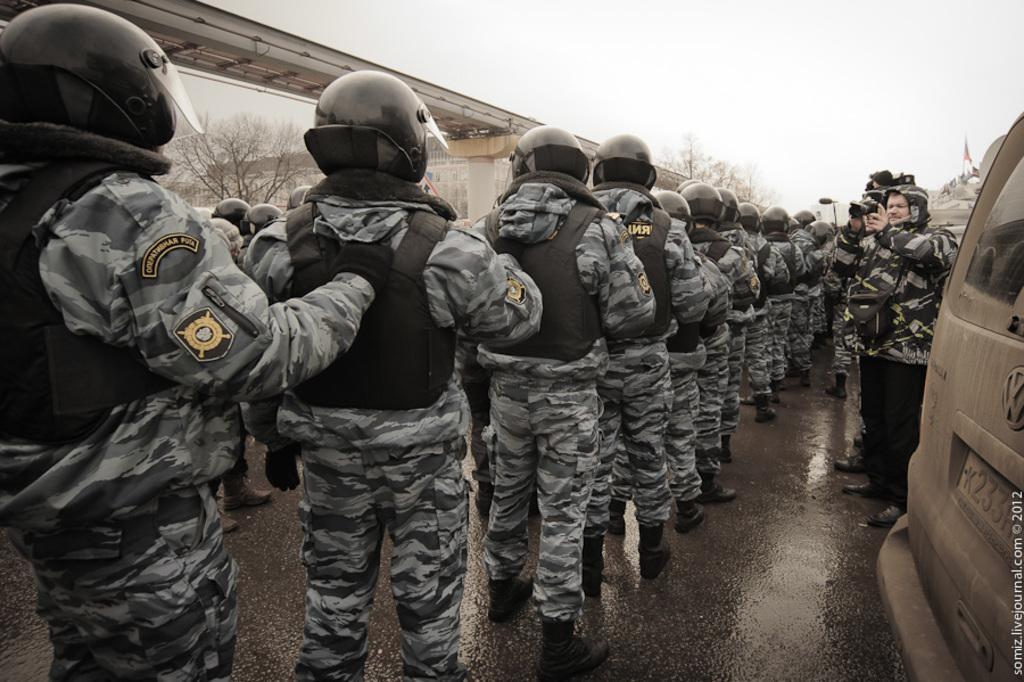How would you summarize this image in a sentence or two? This image is taken outdoors. At the top of the image there is the sky. At the bottom of the image there is a road. In the background there is a bridge with pillars. There is a building and there are a few trees. On the right side of the image a car is parked on the road and there is a flag. A few men are standing and holding cameras in their hands. In the middle of the image many people are standing on the road. 